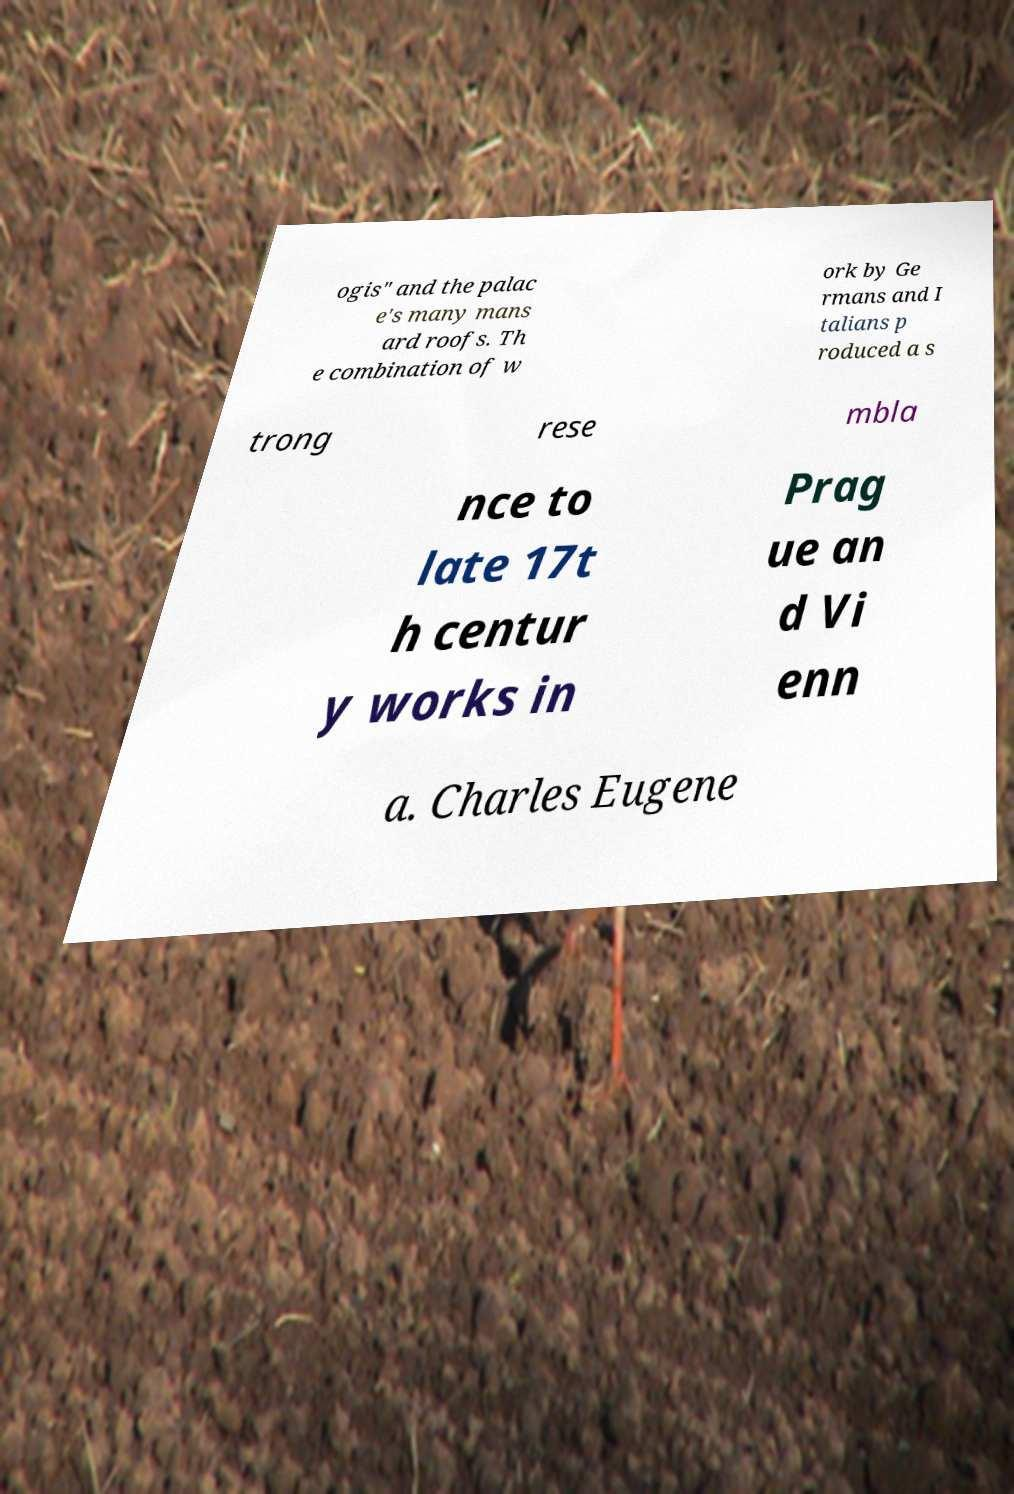Could you extract and type out the text from this image? ogis" and the palac e's many mans ard roofs. Th e combination of w ork by Ge rmans and I talians p roduced a s trong rese mbla nce to late 17t h centur y works in Prag ue an d Vi enn a. Charles Eugene 